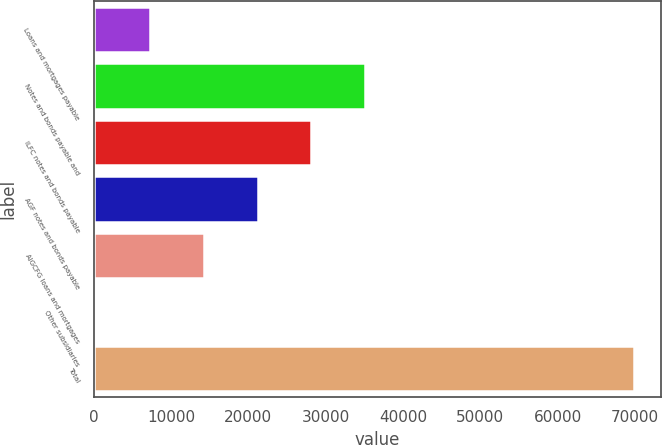Convert chart to OTSL. <chart><loc_0><loc_0><loc_500><loc_500><bar_chart><fcel>Loans and mortgages payable<fcel>Notes and bonds payable and<fcel>ILFC notes and bonds payable<fcel>AGF notes and bonds payable<fcel>AIGCFG loans and mortgages<fcel>Other subsidiaries<fcel>Total<nl><fcel>7296.6<fcel>35107<fcel>28154.4<fcel>21201.8<fcel>14249.2<fcel>344<fcel>69870<nl></chart> 